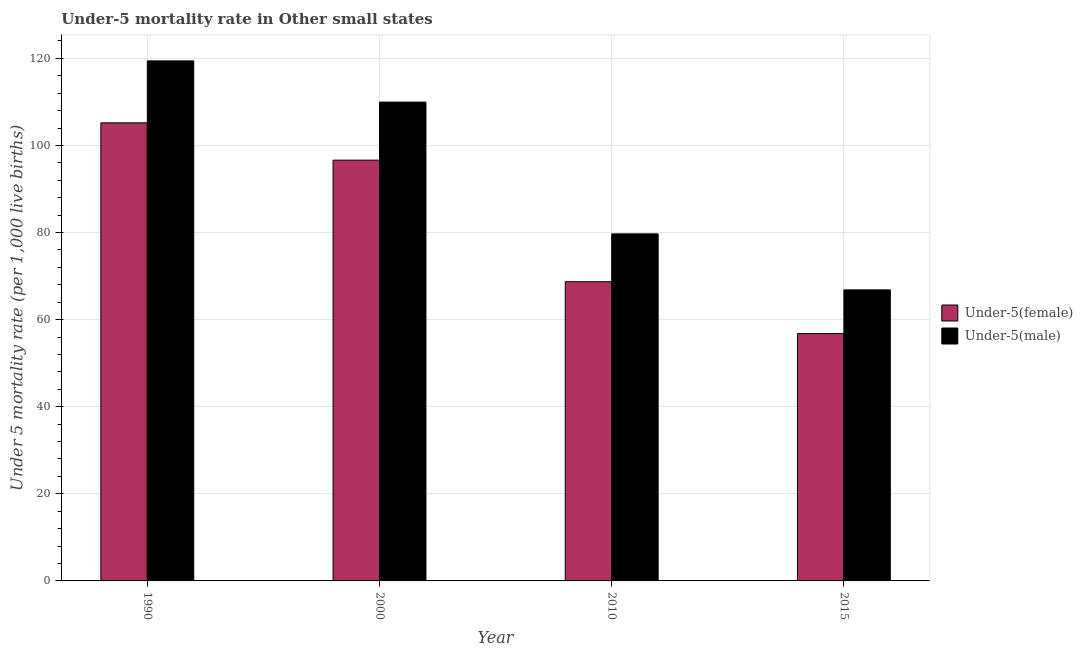Are the number of bars on each tick of the X-axis equal?
Your answer should be very brief. Yes. What is the label of the 4th group of bars from the left?
Your answer should be compact. 2015. In how many cases, is the number of bars for a given year not equal to the number of legend labels?
Your answer should be very brief. 0. What is the under-5 female mortality rate in 1990?
Ensure brevity in your answer.  105.19. Across all years, what is the maximum under-5 female mortality rate?
Ensure brevity in your answer.  105.19. Across all years, what is the minimum under-5 male mortality rate?
Make the answer very short. 66.83. In which year was the under-5 male mortality rate minimum?
Provide a short and direct response. 2015. What is the total under-5 female mortality rate in the graph?
Keep it short and to the point. 327.33. What is the difference between the under-5 male mortality rate in 1990 and that in 2000?
Your response must be concise. 9.47. What is the difference between the under-5 male mortality rate in 2000 and the under-5 female mortality rate in 2010?
Ensure brevity in your answer.  30.26. What is the average under-5 male mortality rate per year?
Your answer should be very brief. 93.97. What is the ratio of the under-5 male mortality rate in 2000 to that in 2010?
Ensure brevity in your answer.  1.38. Is the under-5 female mortality rate in 1990 less than that in 2000?
Your answer should be compact. No. What is the difference between the highest and the second highest under-5 male mortality rate?
Provide a succinct answer. 9.47. What is the difference between the highest and the lowest under-5 male mortality rate?
Your response must be concise. 52.59. Is the sum of the under-5 male mortality rate in 2010 and 2015 greater than the maximum under-5 female mortality rate across all years?
Ensure brevity in your answer.  Yes. What does the 1st bar from the left in 2015 represents?
Keep it short and to the point. Under-5(female). What does the 1st bar from the right in 1990 represents?
Your answer should be compact. Under-5(male). Are all the bars in the graph horizontal?
Make the answer very short. No. How many years are there in the graph?
Keep it short and to the point. 4. Does the graph contain any zero values?
Make the answer very short. No. Does the graph contain grids?
Provide a short and direct response. Yes. How many legend labels are there?
Your answer should be compact. 2. What is the title of the graph?
Offer a terse response. Under-5 mortality rate in Other small states. What is the label or title of the X-axis?
Offer a very short reply. Year. What is the label or title of the Y-axis?
Keep it short and to the point. Under 5 mortality rate (per 1,0 live births). What is the Under 5 mortality rate (per 1,000 live births) in Under-5(female) in 1990?
Your answer should be compact. 105.19. What is the Under 5 mortality rate (per 1,000 live births) of Under-5(male) in 1990?
Make the answer very short. 119.42. What is the Under 5 mortality rate (per 1,000 live births) of Under-5(female) in 2000?
Make the answer very short. 96.62. What is the Under 5 mortality rate (per 1,000 live births) in Under-5(male) in 2000?
Your answer should be compact. 109.95. What is the Under 5 mortality rate (per 1,000 live births) of Under-5(female) in 2010?
Offer a very short reply. 68.7. What is the Under 5 mortality rate (per 1,000 live births) in Under-5(male) in 2010?
Your response must be concise. 79.69. What is the Under 5 mortality rate (per 1,000 live births) in Under-5(female) in 2015?
Keep it short and to the point. 56.81. What is the Under 5 mortality rate (per 1,000 live births) in Under-5(male) in 2015?
Your answer should be very brief. 66.83. Across all years, what is the maximum Under 5 mortality rate (per 1,000 live births) in Under-5(female)?
Ensure brevity in your answer.  105.19. Across all years, what is the maximum Under 5 mortality rate (per 1,000 live births) of Under-5(male)?
Offer a terse response. 119.42. Across all years, what is the minimum Under 5 mortality rate (per 1,000 live births) in Under-5(female)?
Offer a very short reply. 56.81. Across all years, what is the minimum Under 5 mortality rate (per 1,000 live births) in Under-5(male)?
Provide a short and direct response. 66.83. What is the total Under 5 mortality rate (per 1,000 live births) in Under-5(female) in the graph?
Offer a very short reply. 327.33. What is the total Under 5 mortality rate (per 1,000 live births) of Under-5(male) in the graph?
Provide a short and direct response. 375.9. What is the difference between the Under 5 mortality rate (per 1,000 live births) of Under-5(female) in 1990 and that in 2000?
Offer a very short reply. 8.57. What is the difference between the Under 5 mortality rate (per 1,000 live births) of Under-5(male) in 1990 and that in 2000?
Make the answer very short. 9.47. What is the difference between the Under 5 mortality rate (per 1,000 live births) of Under-5(female) in 1990 and that in 2010?
Your answer should be very brief. 36.49. What is the difference between the Under 5 mortality rate (per 1,000 live births) of Under-5(male) in 1990 and that in 2010?
Offer a terse response. 39.73. What is the difference between the Under 5 mortality rate (per 1,000 live births) of Under-5(female) in 1990 and that in 2015?
Your answer should be very brief. 48.38. What is the difference between the Under 5 mortality rate (per 1,000 live births) in Under-5(male) in 1990 and that in 2015?
Your response must be concise. 52.59. What is the difference between the Under 5 mortality rate (per 1,000 live births) of Under-5(female) in 2000 and that in 2010?
Your answer should be compact. 27.92. What is the difference between the Under 5 mortality rate (per 1,000 live births) of Under-5(male) in 2000 and that in 2010?
Keep it short and to the point. 30.26. What is the difference between the Under 5 mortality rate (per 1,000 live births) of Under-5(female) in 2000 and that in 2015?
Ensure brevity in your answer.  39.82. What is the difference between the Under 5 mortality rate (per 1,000 live births) of Under-5(male) in 2000 and that in 2015?
Provide a short and direct response. 43.12. What is the difference between the Under 5 mortality rate (per 1,000 live births) of Under-5(female) in 2010 and that in 2015?
Offer a terse response. 11.9. What is the difference between the Under 5 mortality rate (per 1,000 live births) in Under-5(male) in 2010 and that in 2015?
Your response must be concise. 12.86. What is the difference between the Under 5 mortality rate (per 1,000 live births) of Under-5(female) in 1990 and the Under 5 mortality rate (per 1,000 live births) of Under-5(male) in 2000?
Keep it short and to the point. -4.76. What is the difference between the Under 5 mortality rate (per 1,000 live births) of Under-5(female) in 1990 and the Under 5 mortality rate (per 1,000 live births) of Under-5(male) in 2010?
Offer a very short reply. 25.5. What is the difference between the Under 5 mortality rate (per 1,000 live births) in Under-5(female) in 1990 and the Under 5 mortality rate (per 1,000 live births) in Under-5(male) in 2015?
Offer a terse response. 38.36. What is the difference between the Under 5 mortality rate (per 1,000 live births) in Under-5(female) in 2000 and the Under 5 mortality rate (per 1,000 live births) in Under-5(male) in 2010?
Ensure brevity in your answer.  16.93. What is the difference between the Under 5 mortality rate (per 1,000 live births) in Under-5(female) in 2000 and the Under 5 mortality rate (per 1,000 live births) in Under-5(male) in 2015?
Offer a terse response. 29.79. What is the difference between the Under 5 mortality rate (per 1,000 live births) in Under-5(female) in 2010 and the Under 5 mortality rate (per 1,000 live births) in Under-5(male) in 2015?
Your response must be concise. 1.87. What is the average Under 5 mortality rate (per 1,000 live births) in Under-5(female) per year?
Provide a short and direct response. 81.83. What is the average Under 5 mortality rate (per 1,000 live births) in Under-5(male) per year?
Offer a terse response. 93.97. In the year 1990, what is the difference between the Under 5 mortality rate (per 1,000 live births) of Under-5(female) and Under 5 mortality rate (per 1,000 live births) of Under-5(male)?
Offer a very short reply. -14.23. In the year 2000, what is the difference between the Under 5 mortality rate (per 1,000 live births) of Under-5(female) and Under 5 mortality rate (per 1,000 live births) of Under-5(male)?
Give a very brief answer. -13.33. In the year 2010, what is the difference between the Under 5 mortality rate (per 1,000 live births) in Under-5(female) and Under 5 mortality rate (per 1,000 live births) in Under-5(male)?
Give a very brief answer. -10.99. In the year 2015, what is the difference between the Under 5 mortality rate (per 1,000 live births) in Under-5(female) and Under 5 mortality rate (per 1,000 live births) in Under-5(male)?
Give a very brief answer. -10.03. What is the ratio of the Under 5 mortality rate (per 1,000 live births) of Under-5(female) in 1990 to that in 2000?
Your answer should be compact. 1.09. What is the ratio of the Under 5 mortality rate (per 1,000 live births) in Under-5(male) in 1990 to that in 2000?
Ensure brevity in your answer.  1.09. What is the ratio of the Under 5 mortality rate (per 1,000 live births) of Under-5(female) in 1990 to that in 2010?
Provide a succinct answer. 1.53. What is the ratio of the Under 5 mortality rate (per 1,000 live births) in Under-5(male) in 1990 to that in 2010?
Your answer should be compact. 1.5. What is the ratio of the Under 5 mortality rate (per 1,000 live births) of Under-5(female) in 1990 to that in 2015?
Your answer should be compact. 1.85. What is the ratio of the Under 5 mortality rate (per 1,000 live births) of Under-5(male) in 1990 to that in 2015?
Ensure brevity in your answer.  1.79. What is the ratio of the Under 5 mortality rate (per 1,000 live births) of Under-5(female) in 2000 to that in 2010?
Offer a very short reply. 1.41. What is the ratio of the Under 5 mortality rate (per 1,000 live births) in Under-5(male) in 2000 to that in 2010?
Provide a short and direct response. 1.38. What is the ratio of the Under 5 mortality rate (per 1,000 live births) of Under-5(female) in 2000 to that in 2015?
Your response must be concise. 1.7. What is the ratio of the Under 5 mortality rate (per 1,000 live births) in Under-5(male) in 2000 to that in 2015?
Your answer should be compact. 1.65. What is the ratio of the Under 5 mortality rate (per 1,000 live births) of Under-5(female) in 2010 to that in 2015?
Give a very brief answer. 1.21. What is the ratio of the Under 5 mortality rate (per 1,000 live births) of Under-5(male) in 2010 to that in 2015?
Keep it short and to the point. 1.19. What is the difference between the highest and the second highest Under 5 mortality rate (per 1,000 live births) in Under-5(female)?
Your answer should be very brief. 8.57. What is the difference between the highest and the second highest Under 5 mortality rate (per 1,000 live births) of Under-5(male)?
Ensure brevity in your answer.  9.47. What is the difference between the highest and the lowest Under 5 mortality rate (per 1,000 live births) of Under-5(female)?
Offer a terse response. 48.38. What is the difference between the highest and the lowest Under 5 mortality rate (per 1,000 live births) of Under-5(male)?
Ensure brevity in your answer.  52.59. 